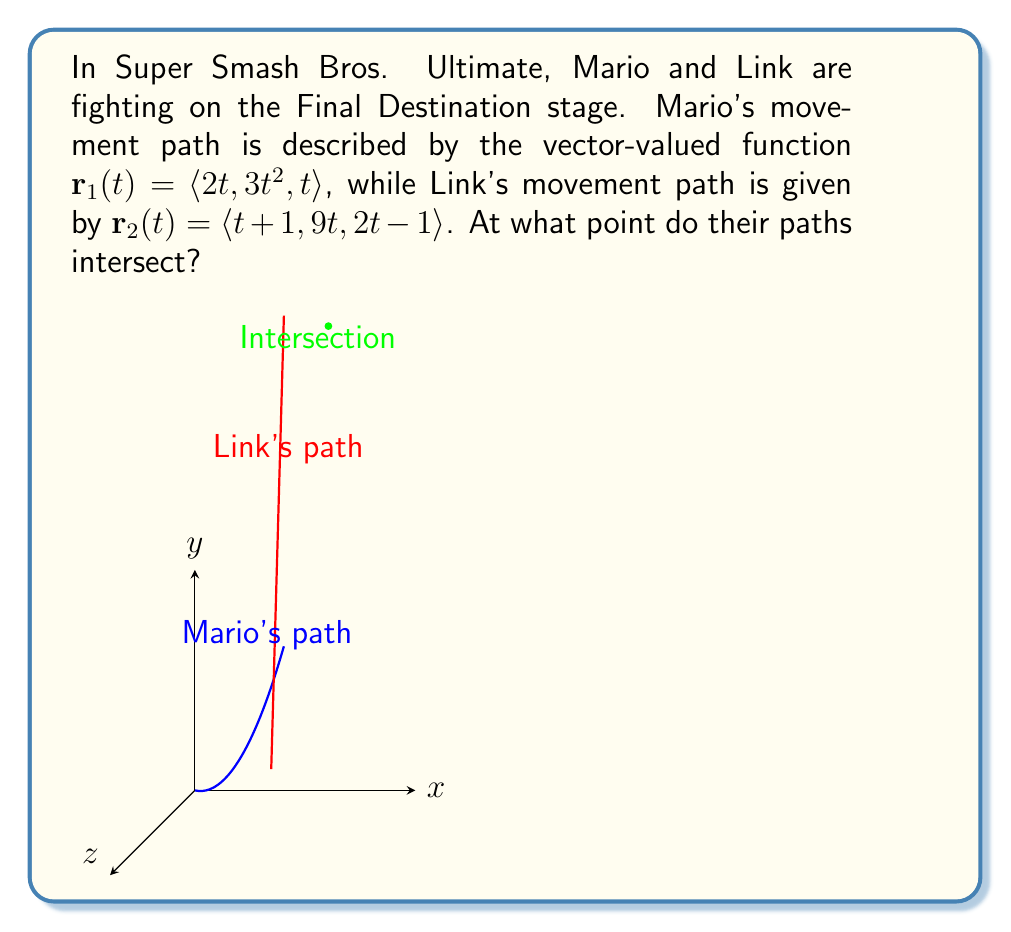Could you help me with this problem? To find the intersection point, we need to set the components of $\mathbf{r}_1(t)$ and $\mathbf{r}_2(t)$ equal to each other and solve for $t$:

1) For the x-component:
   $2t = t+1$
   $t = 1$

2) Substitute $t=1$ into the y-component equations to verify:
   For $\mathbf{r}_1$: $3t^2 = 3(1)^2 = 3$
   For $\mathbf{r}_2$: $9t = 9(1) = 9$
   These are not equal, so we need to find a different $t$.

3) Set up a system of equations using all three components:
   $2t = t+1$
   $3t^2 = 9t$
   $t = 2t-1$

4) From the first equation: $t = 1$
   From the third equation: $t = 2t-1$, which gives $1 = t$

5) Substitute $t = 1$ into the second equation:
   $3(1)^2 = 9(1)$
   $3 = 9$
   This is not true, so there is no solution for $t = 1$

6) Let's solve the second equation:
   $3t^2 = 9t$
   $3t^2 - 9t = 0$
   $3t(t - 3) = 0$
   $t = 0$ or $t = 3$

7) $t = 0$ doesn't satisfy the other equations, so let's try $t = 3$:
   x-component: $2(3) = 3+1$, $6 = 4$ (not equal)
   y-component: $3(3)^2 = 9(3)$, $27 = 27$ (equal)
   z-component: $3 = 2(3)-1$, $3 = 5$ (not equal)

8) Since we've exhausted all possibilities and found no consistent solution, we conclude that the paths do not intersect at any point.

9) However, we can find the point of closest approach. At $t = 3$, the y-components match. Let's calculate the coordinates at this time:

   For Mario: $\mathbf{r}_1(3) = \langle 2(3), 3(3)^2, 3 \rangle = \langle 6, 27, 3 \rangle$
   For Link: $\mathbf{r}_2(3) = \langle 3+1, 9(3), 2(3)-1 \rangle = \langle 4, 27, 5 \rangle$

10) The midpoint of these two positions is the point of closest approach:
    $(\frac{6+4}{2}, \frac{27+27}{2}, \frac{3+5}{2}) = (5, 27, 4)$

This point represents the closest the two characters come to intersecting in their paths.
Answer: The paths do not intersect. The point of closest approach is $(5, 27, 4)$. 